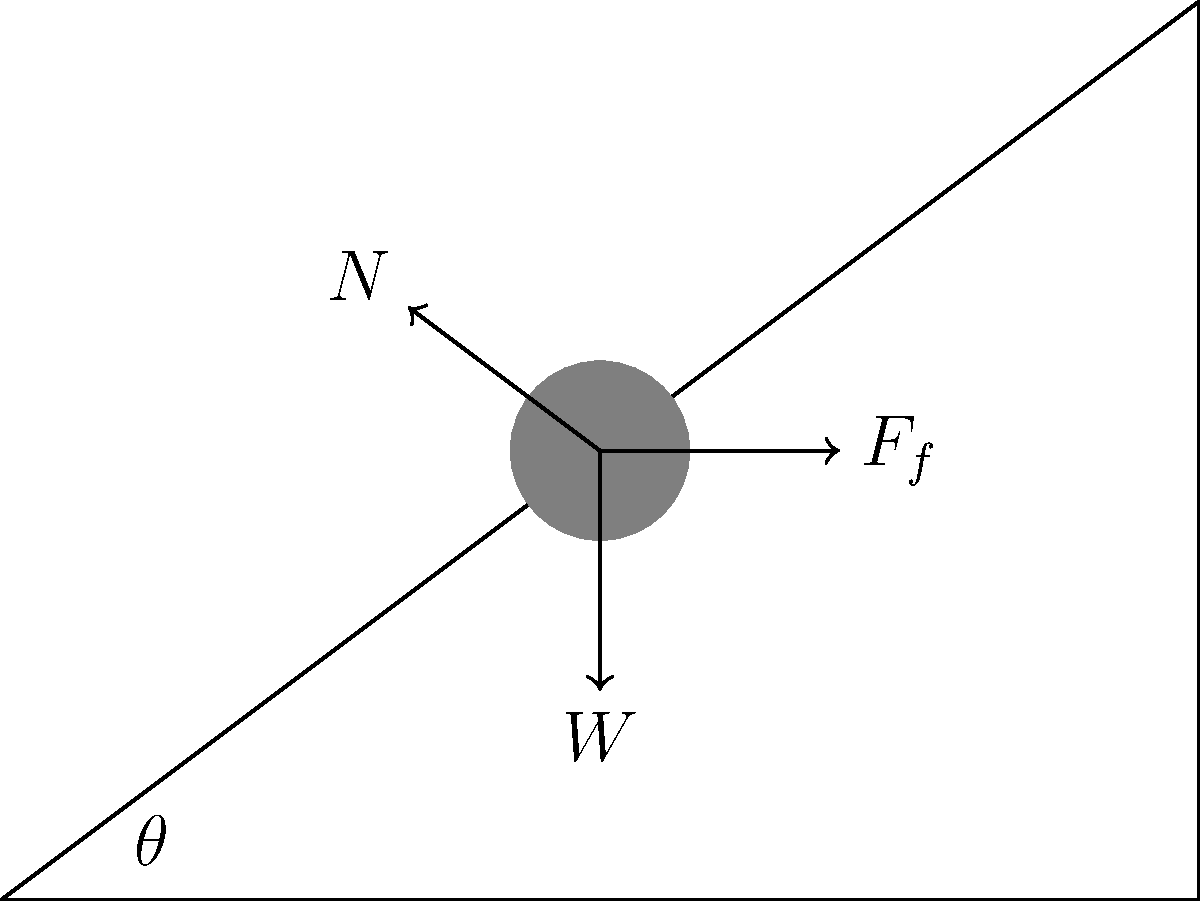Analyze the forces acting on the object in the diagram. What's the relationship between the normal force ($N$) and the weight ($W$) of the object on this inclined plane? 1. Identify forces: Weight ($W$), Normal force ($N$), and Friction ($F_f$).
2. Decompose weight into components parallel and perpendicular to the plane.
3. $W_\parallel = W \sin\theta$ (down the plane)
4. $W_\perp = W \cos\theta$ (into the plane)
5. Normal force $N$ balances $W_\perp$.
6. Therefore, $N = W \cos\theta$.
7. Relationship: $N$ is the component of $W$ perpendicular to the plane.
Answer: $N = W \cos\theta$ 